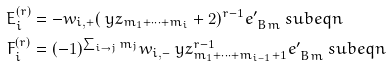Convert formula to latex. <formula><loc_0><loc_0><loc_500><loc_500>E _ { i } ^ { ( r ) } & = - w _ { i , + } ( \ y z _ { m _ { 1 } + \dots + m _ { i } } + 2 ) ^ { r - 1 } e ^ { \prime } _ { \ B m } \ s u b e q n \\ F _ { i } ^ { ( r ) } & = ( - 1 ) ^ { \sum _ { i \rightarrow j } m _ { j } } w _ { i , - } \ y z _ { m _ { 1 } + \dots + m _ { i - 1 } + 1 } ^ { r - 1 } e ^ { \prime } _ { \ B m } \ s u b e q n</formula> 